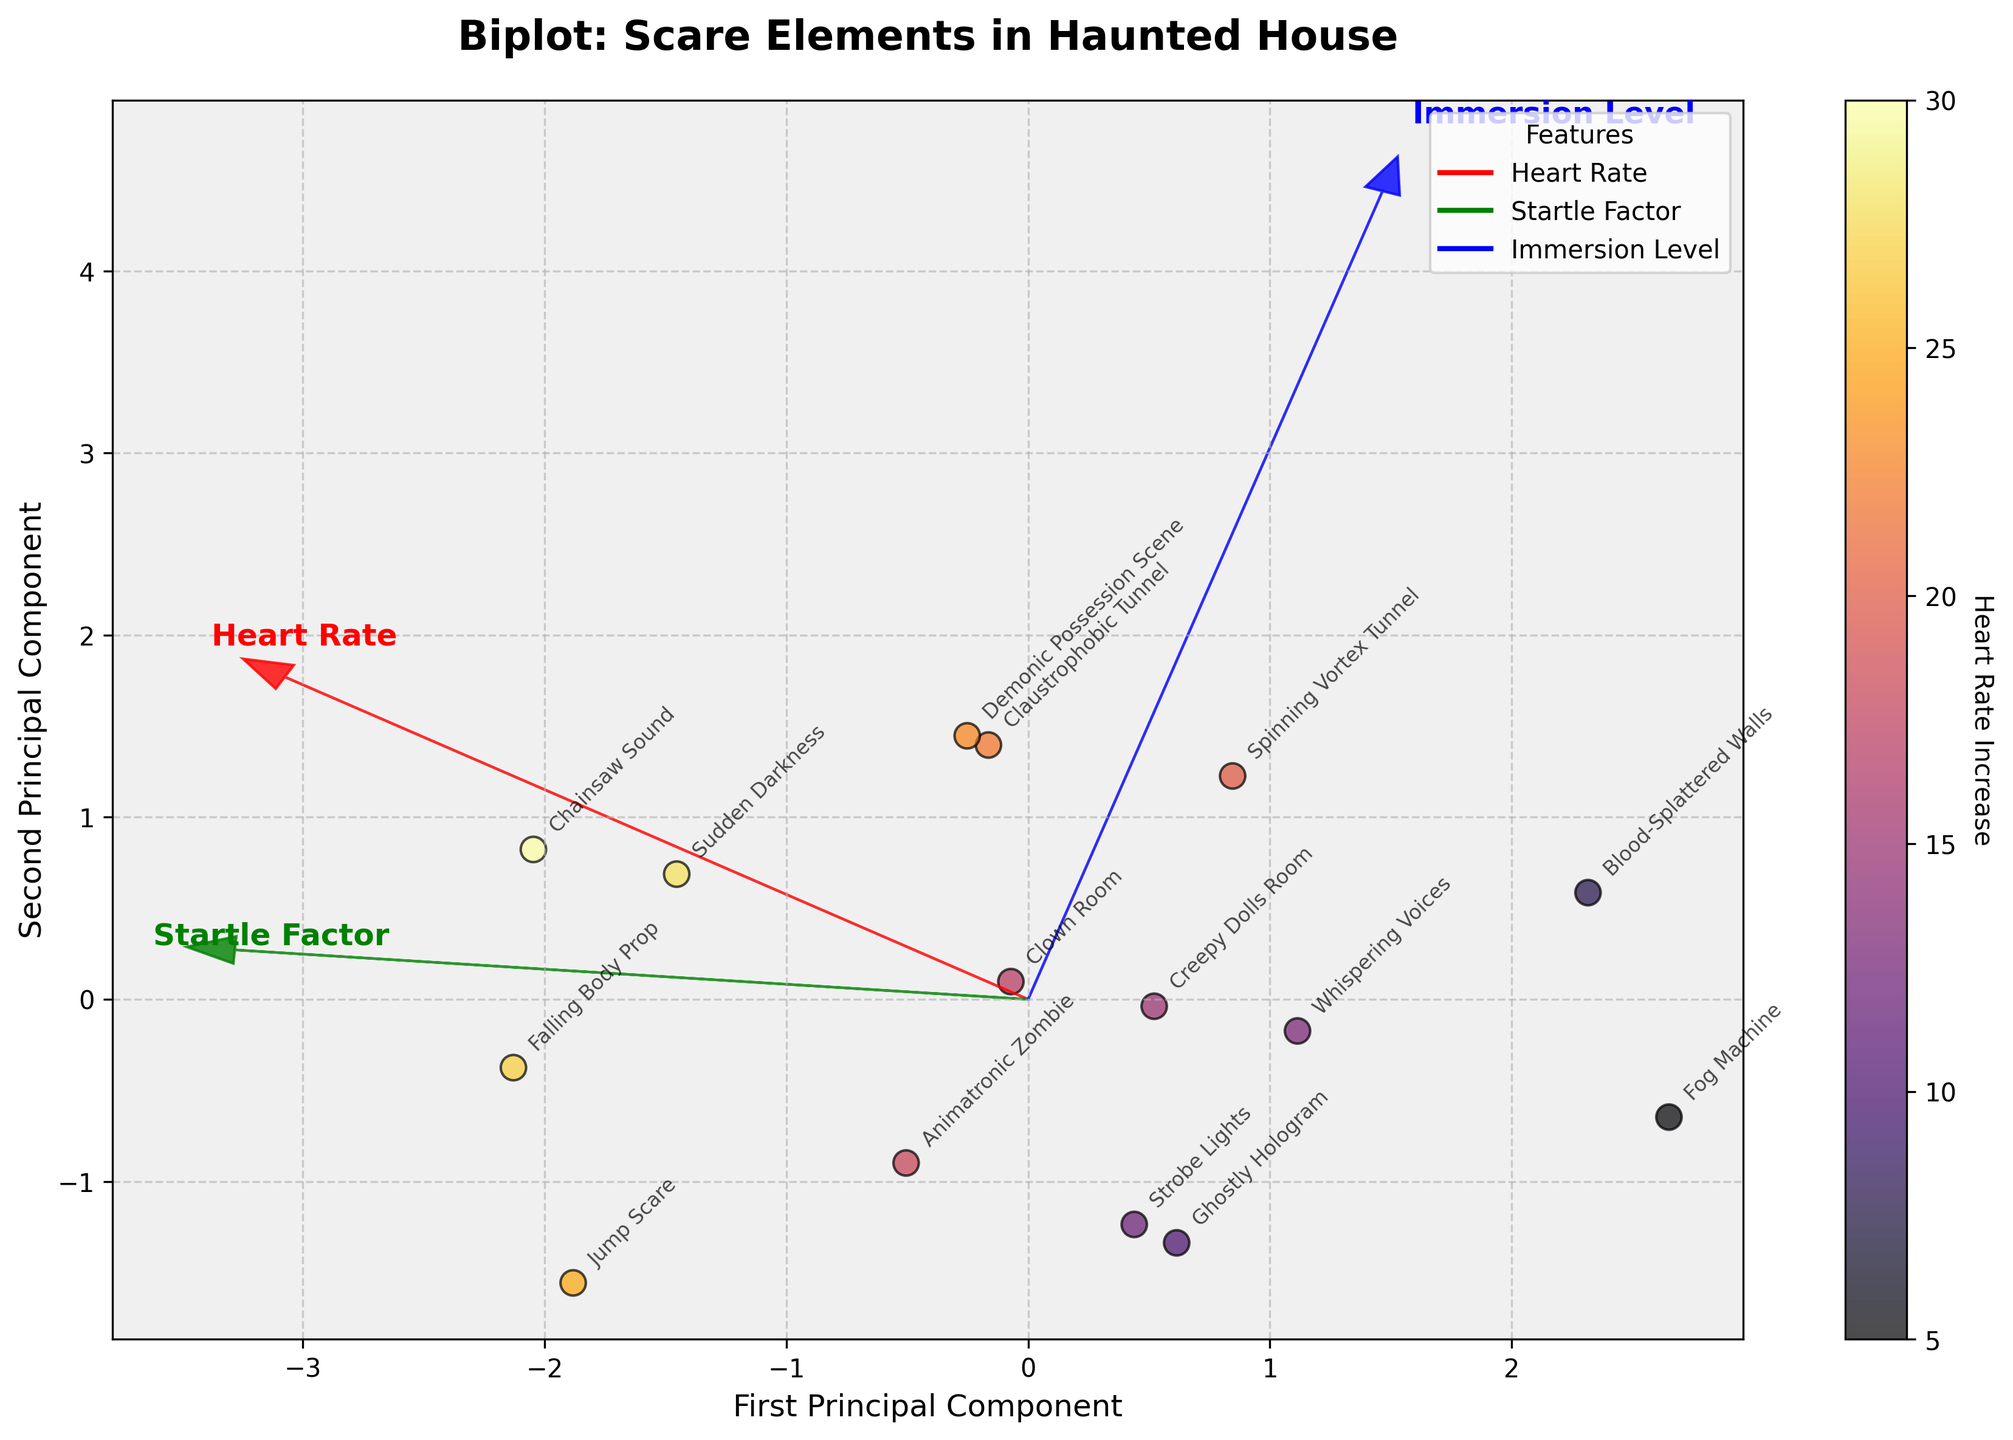How many principal components are plotted on the x and y axes? The title mentions "First Principal Component" and "Second Principal Component" as the x and y axes, respectively. Therefore, the plot uses two principal components.
Answer: 2 What does the color of the data points represent? The color of the data points is indicated by a colorbar labeled "Heart Rate Increase." This shows that the color represents the increase in heart rate caused by each scare element.
Answer: Heart Rate Increase Which scare element seems to have the highest heart rate increase? By observing the darkest shaded data point, which represents the highest heart rate increase, we note the closest label. The "Chainsaw Sound" seems to be the darkest point on the plot.
Answer: Chainsaw Sound Compare the startle factor of "Jump Scare" and "Fog Machine" relative to their position on the first principal component. On the first principal component, "Jump Scare" and "Fog Machine" are placed far apart, with "Jump Scare" on the higher positive side suggesting a higher startle factor while "Fog Machine" is on the lower end suggesting a lower startle factor.
Answer: Jump Scare > Fog Machine Which feature vector is the longest, indicating the most variance explained? The length of the arrow vectors represents the amount of variance explained by that feature. Observing the vectors, "Heart Rate" has the longest vector, indicating it explains the most variance.
Answer: Heart Rate How does "Sudden Darkness" compare to "Ghostly Hologram" in terms of immersion level? "Sudden Darkness" and "Ghostly Hologram" can be compared by looking at their relative positions to the blue 'Immersion Level' arrow. "Sudden Darkness" is closer and aligned more significantly, indicating a higher immersion level than the "Ghostly Hologram."
Answer: Sudden Darkness > Ghostly Hologram Which scare elements are closest to each other on the plot? By examining the plot, "Demonic Possession Scene" and "Claustrophobic Tunnel" appear to be closest to each other in proximity, suggesting similar characteristics.
Answer: Demonic Possession Scene and Claustrophobic Tunnel What does the direction of the "Startle Factor" vector suggest about the scare elements? The direction of the "Startle Factor" vector indicates that scare elements along the direction of this arrow (positive x and y direction) tend to have higher startle factors.
Answer: Higher startle factor in positive x and y direction What relationship can you infer between the "Heart Rate Increase" and "Startle Factor" from their feature vectors? The "Heart Rate Increase" and "Startle Factor" vectors point in a similar direction, suggesting a positive correlation—scare elements with higher startle factors tend also to cause bigger heart rate increases.
Answer: Positive correlation What is the total increase in heart rate for "Chainsaw Sound" and "Falling Body Prop"? From the color shading and data annotation, "Chainsaw Sound" and "Falling Body Prop" increase the heart rate by 30 and 27 respectively. Adding them: 30 + 27 = 57.
Answer: 57 